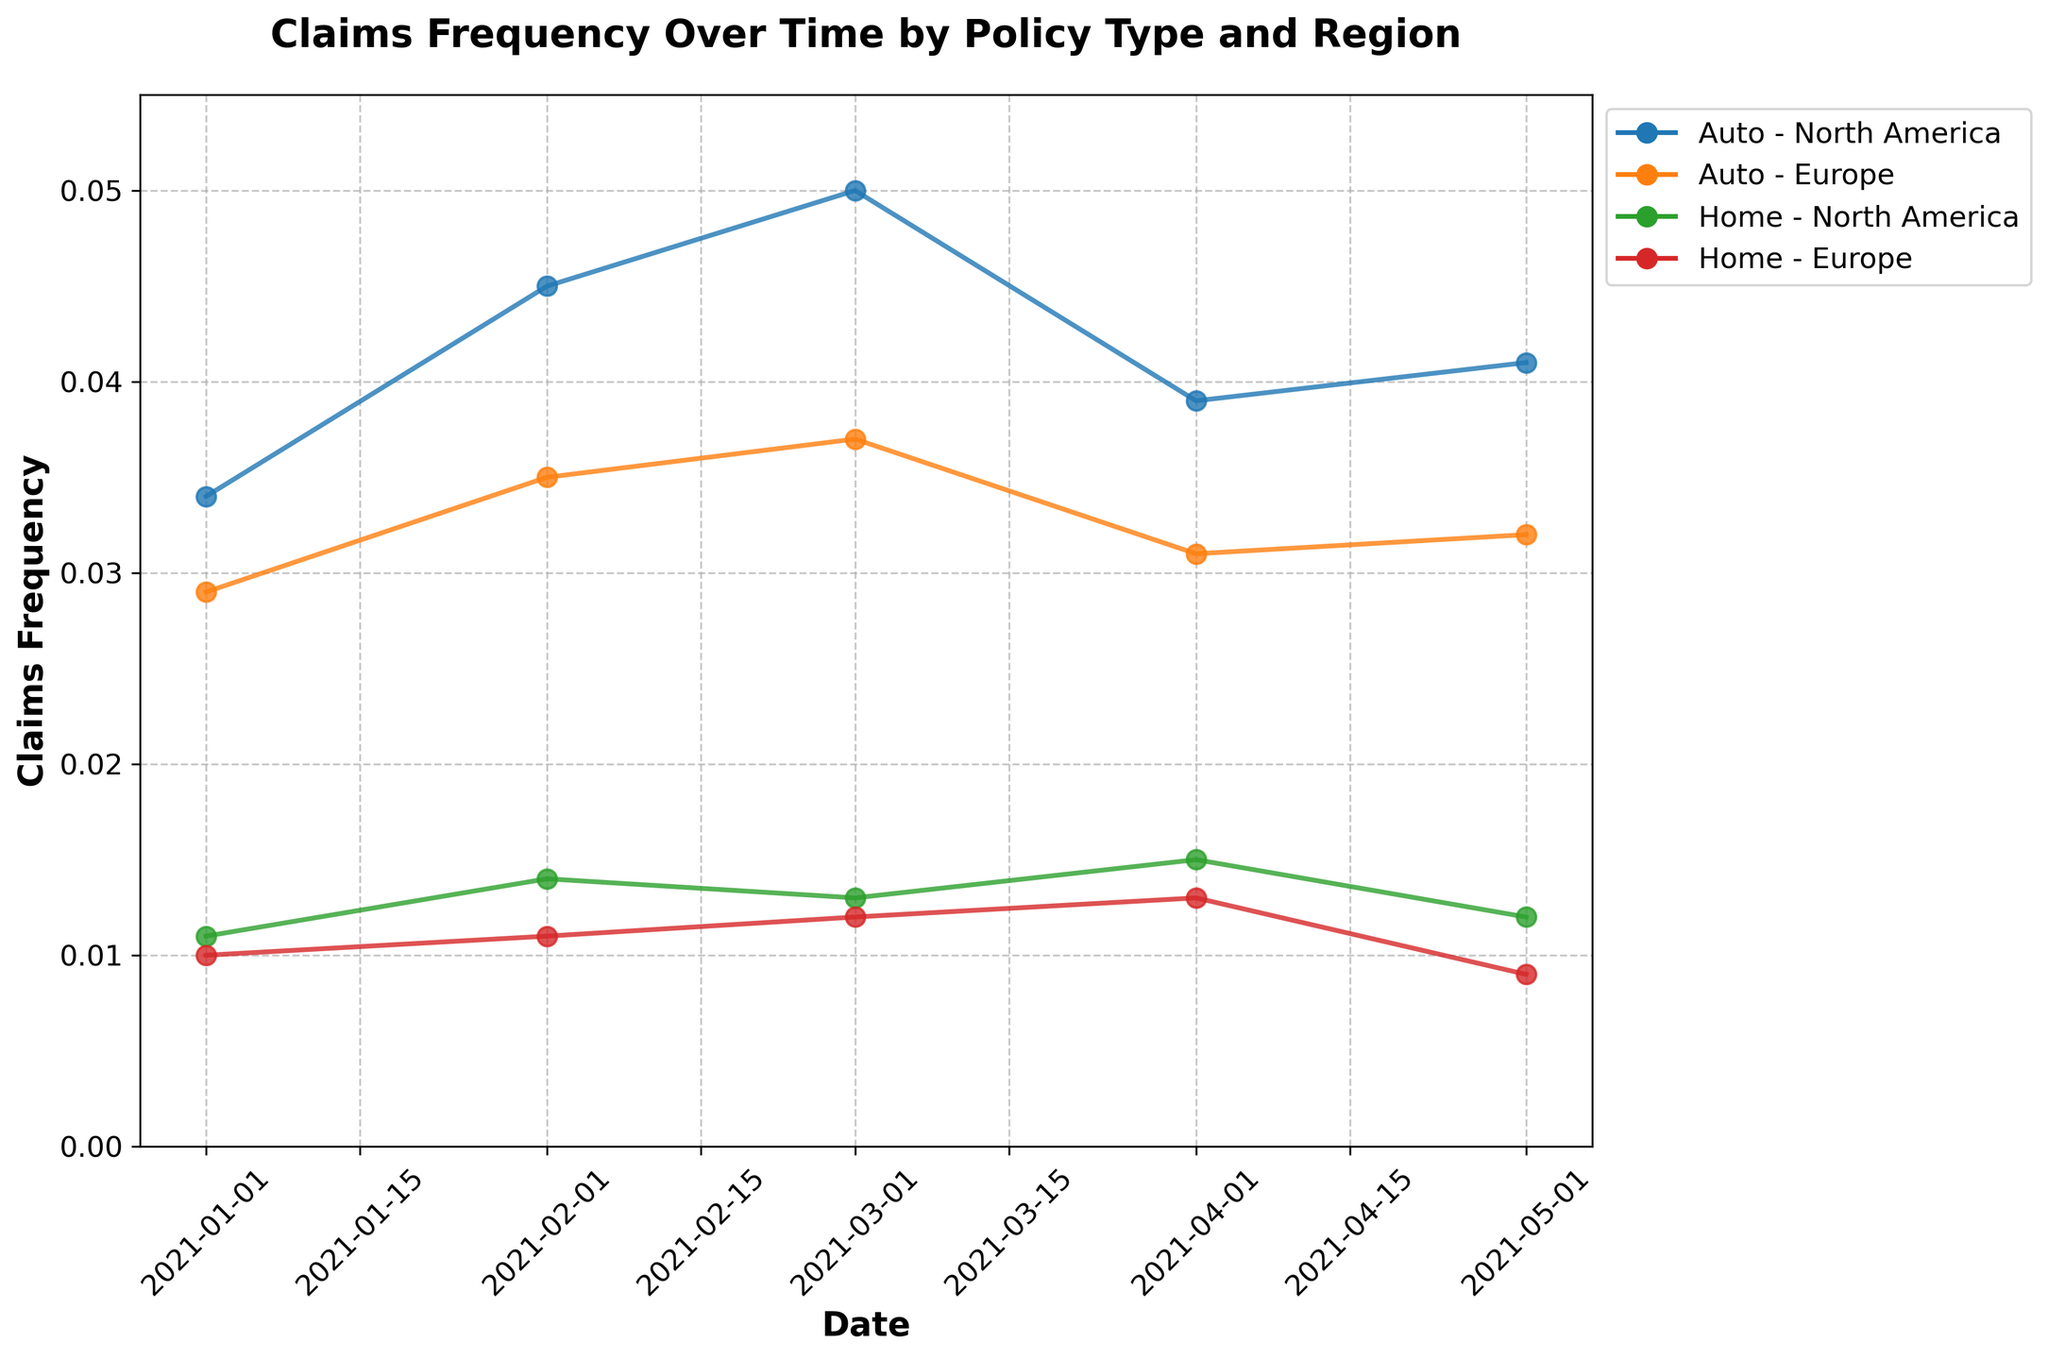What's the title of the plot? The title is typically placed at the top center of the plot and provides an overview of the graphical representation. Here, the title is clearly written.
Answer: Claims Frequency Over Time by Policy Type and Region What is the axis label for the y-axis? The y-axis label indicates the variable being represented along this axis. In this case, it states what the y-axis measures.
Answer: Claims Frequency How many lines are plotted in the figure? Each line represents a combination of a policy type and a region. Counting these lines provides the total number of distinct combinations shown in the plot. There are lines for Auto and Home policies, each split by North America and Europe.
Answer: 4 Which policy type and region combination shows the highest claims frequency? By scanning the plot, identify the peak value across all lines. The line reaching the highest point represents the combination with the highest claims frequency. In this case, the peak is within the Auto policy in North America.
Answer: Auto - North America What is the trend in claims frequency for the Home policy in Europe over time? Examine the line corresponding to the Home policy in Europe. Observe the changes in the line's height over the months. Initially, there is a small increase followed by a decrease towards the end.
Answer: Slight increase, then decrease Which combination shows the most stable claims frequency over time? A stable trend would show minimal variation in the line's vertical position. By visually comparing the fluctuations across lines, determine the one with the least variability. The Home policy in Europe shows the least change over time.
Answer: Home - Europe Compare the claims frequency for Auto policies in North America and Europe in March 2021. Locate the points for March 2021 on both lines corresponding to Auto policies in North America and Europe. Compare their vertical positions. The plot shows that the value is higher for North America.
Answer: Higher in North America Calculate the average claims frequency for Home policies in North America during the first quarter of 2021. Sum the values for January, February, and March (0.011 + 0.014 + 0.013) and divide by the number of months (3) to find the average.
Answer: 0.0127 By how much did the claims frequency for Auto policies in Europe change between April and May 2021? Identify the values at April and May for Auto policies in Europe (0.031 in April and 0.032 in May). Calculate the difference (0.032 - 0.031).
Answer: 0.001 